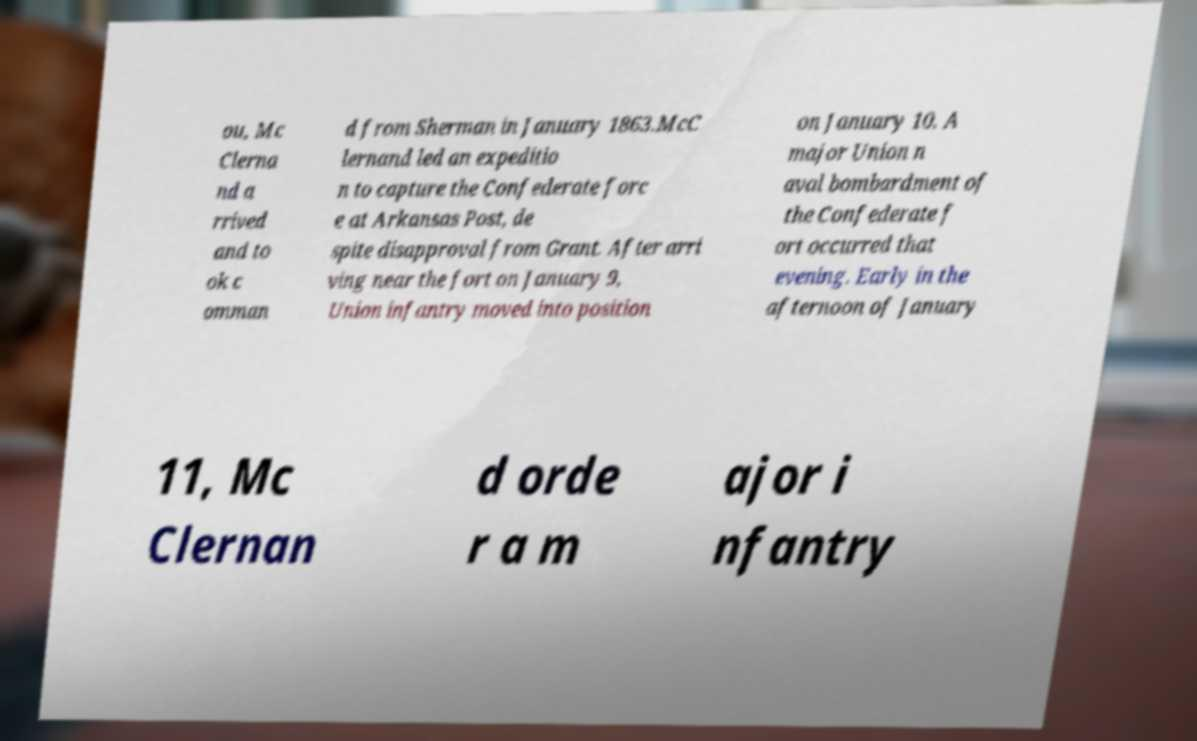For documentation purposes, I need the text within this image transcribed. Could you provide that? ou, Mc Clerna nd a rrived and to ok c omman d from Sherman in January 1863.McC lernand led an expeditio n to capture the Confederate forc e at Arkansas Post, de spite disapproval from Grant. After arri ving near the fort on January 9, Union infantry moved into position on January 10. A major Union n aval bombardment of the Confederate f ort occurred that evening. Early in the afternoon of January 11, Mc Clernan d orde r a m ajor i nfantry 